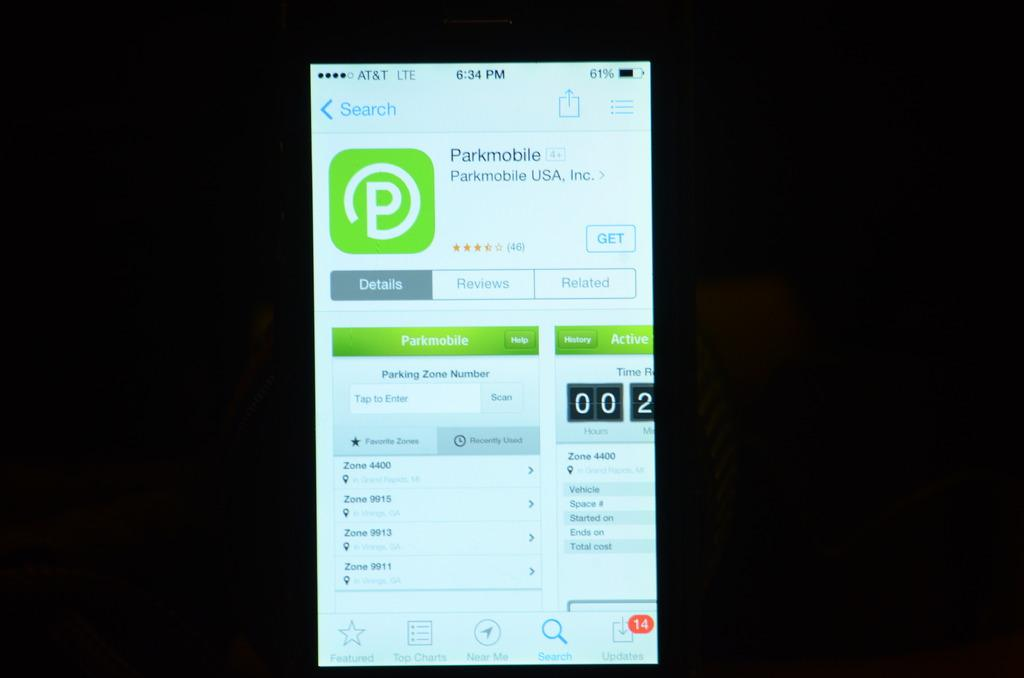<image>
Share a concise interpretation of the image provided. An app called Parkmobile with an option to show reviews 